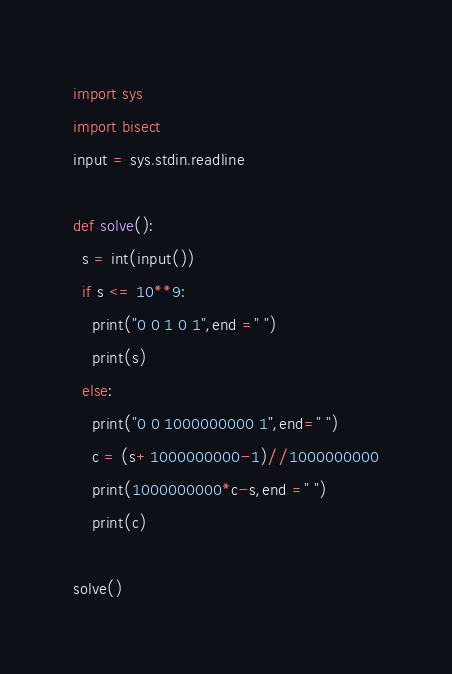Convert code to text. <code><loc_0><loc_0><loc_500><loc_500><_Python_>import sys
import bisect
input = sys.stdin.readline

def solve():
  s = int(input())
  if s <= 10**9:
    print("0 0 1 0 1",end =" ")
    print(s)
  else:
    print("0 0 1000000000 1",end=" ")
    c = (s+1000000000-1)//1000000000
    print(1000000000*c-s,end =" ")
    print(c)
    
solve()</code> 